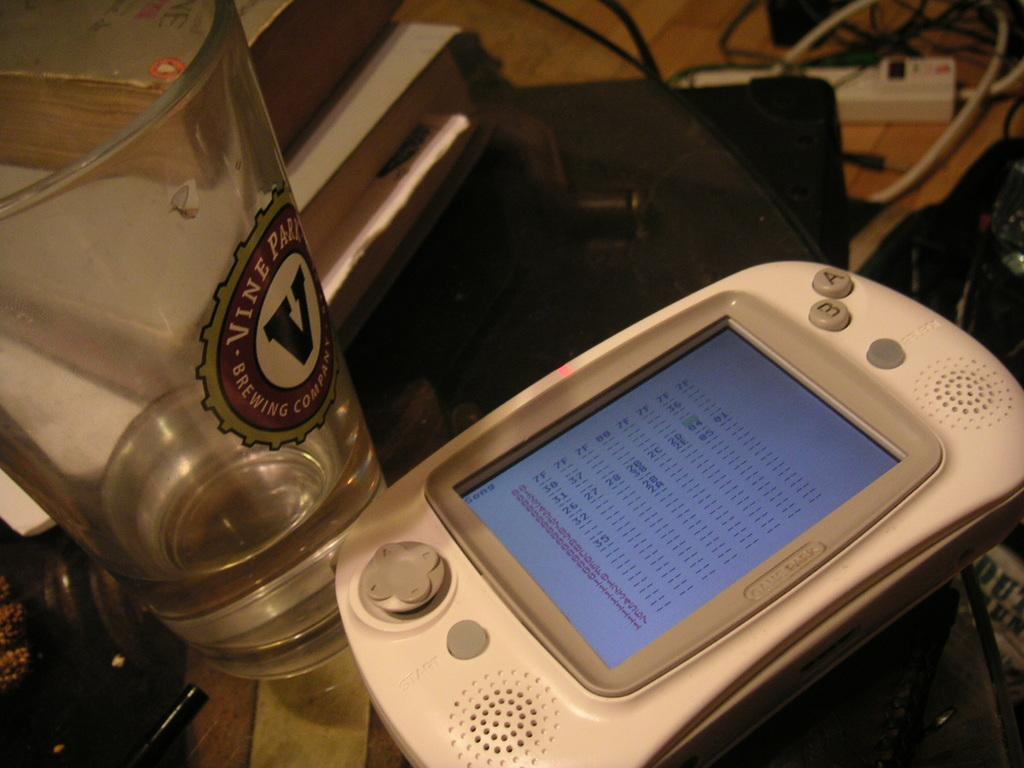<image>
Present a compact description of the photo's key features. a hex code reader next to a glass reading VINE 